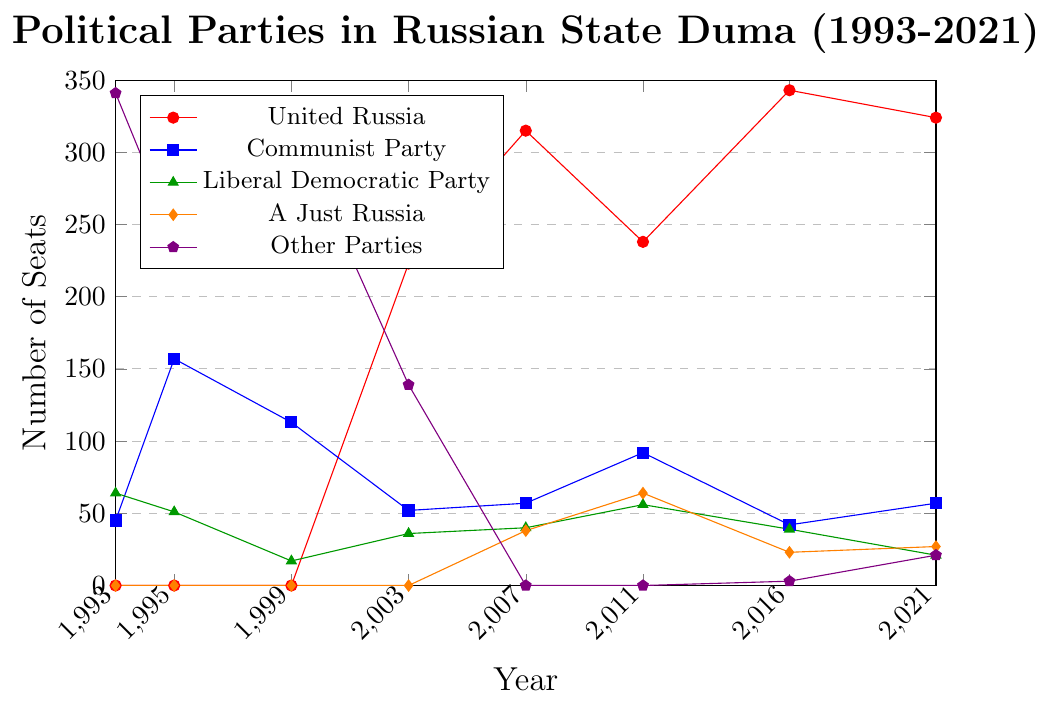What year did United Russia first appear with significant representation in the State Duma? United Russia first appears in the data set with significant seats in 2003. Looking at the trend, from 1993 to 1999, they had zero seats, but in 2003, they obtained 223 seats.
Answer: 2003 Which party had the most seats in 1993? In 1993, the "Other Parties" category had the most seats with 341 seats. This value is higher than any other party's seats in that year.
Answer: Other Parties How did the number of seats for the Communist Party change from 1995 to 1999? In 1995, the Communist Party had 157 seats, and by 1999, it had 113 seats. The change is calculated by subtracting 113 from 157, resulting in a decrease of 44 seats.
Answer: Decreased by 44 What is the trend for A Just Russia from 2007 to 2021? A Just Russia first appears in 2007 with 38 seats, increases to 64 seats in 2011, then decreases to 23 seats in 2016, and slightly increases to 27 seats in 2021. The overall trend is an initial increase followed by a decrease.
Answer: Initial increase, then decrease Which parties gained seats between 2016 and 2021? Comparing the data for 2016 and 2021, "Communist Party" increased from 42 to 57 seats, and "A Just Russia" increased from 23 to 27 seats, while the "Other Parties" category increased from 3 to 21 seats.
Answer: Communist Party, A Just Russia, Other Parties In which year did United Russia have the highest number of seats? Among the years shown, United Russia had the highest number of seats in 2016 with 343 seats.
Answer: 2016 Which party consistently had representation every year shown in the data? The Communist Party and the Liberal Democratic Party had representation in all years from 1993 to 2021.
Answer: Communist Party and Liberal Democratic Party What is the overall trend observed for the "Other Parties" category from 1993 to 2021? "Other Parties" start with high representation in 1993 and 1995, then decrease significantly in 1999 and hit zero in 2007 and 2011 before slightly rebounding in 2016 and 2021. Overall, the trend shows a significant decline followed by a minimal increase.
Answer: Decline then minimal increase 